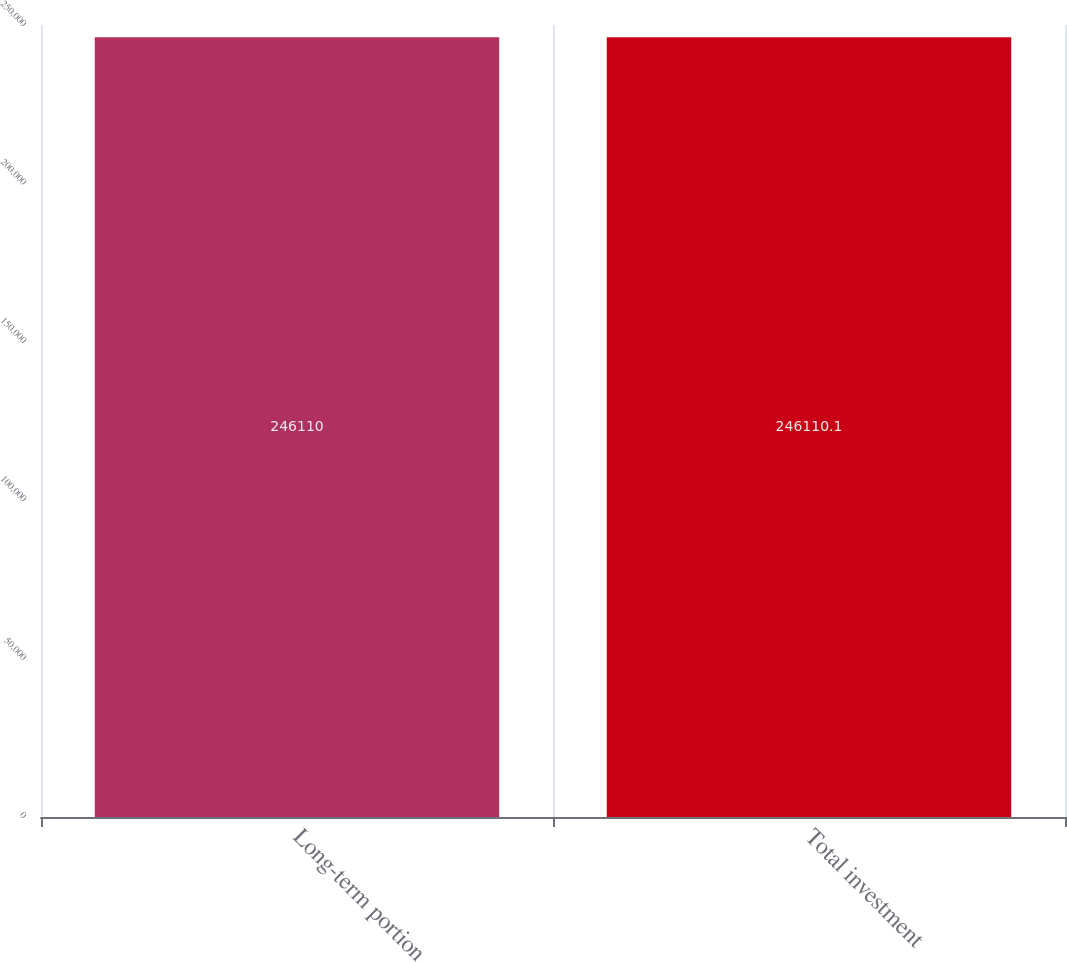Convert chart to OTSL. <chart><loc_0><loc_0><loc_500><loc_500><bar_chart><fcel>Long-term portion<fcel>Total investment<nl><fcel>246110<fcel>246110<nl></chart> 